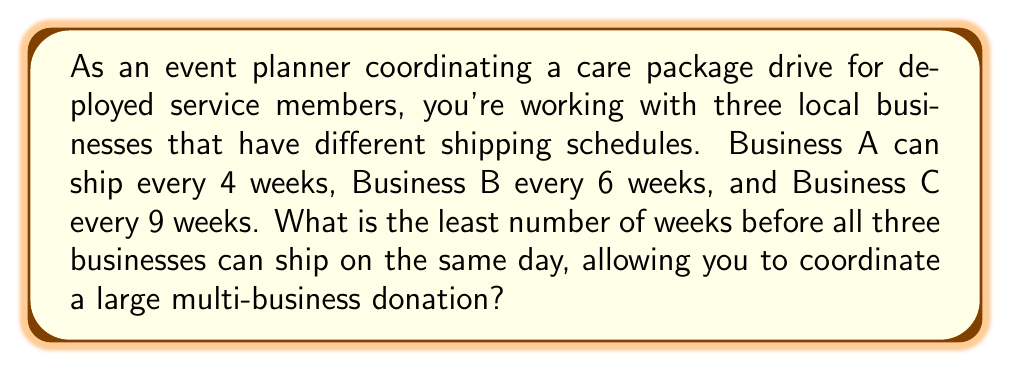Can you solve this math problem? To solve this problem, we need to find the least common multiple (LCM) of the three shipping schedules: 4, 6, and 9 weeks.

Step 1: Find the prime factorization of each number
$4 = 2^2$
$6 = 2 \times 3$
$9 = 3^2$

Step 2: To find the LCM, we take each prime factor to the highest power in which it occurs in any of the numbers:

$LCM(4,6,9) = 2^2 \times 3^2$

Step 3: Calculate the result
$LCM(4,6,9) = 4 \times 9 = 36$

Therefore, the least number of weeks before all three businesses can ship on the same day is 36 weeks.

We can verify this:
- Business A: $36 \div 4 = 9$ (whole number)
- Business B: $36 \div 6 = 6$ (whole number)
- Business C: $36 \div 9 = 4$ (whole number)

This confirms that 36 weeks is indeed the least common multiple of the three shipping schedules.
Answer: 36 weeks 